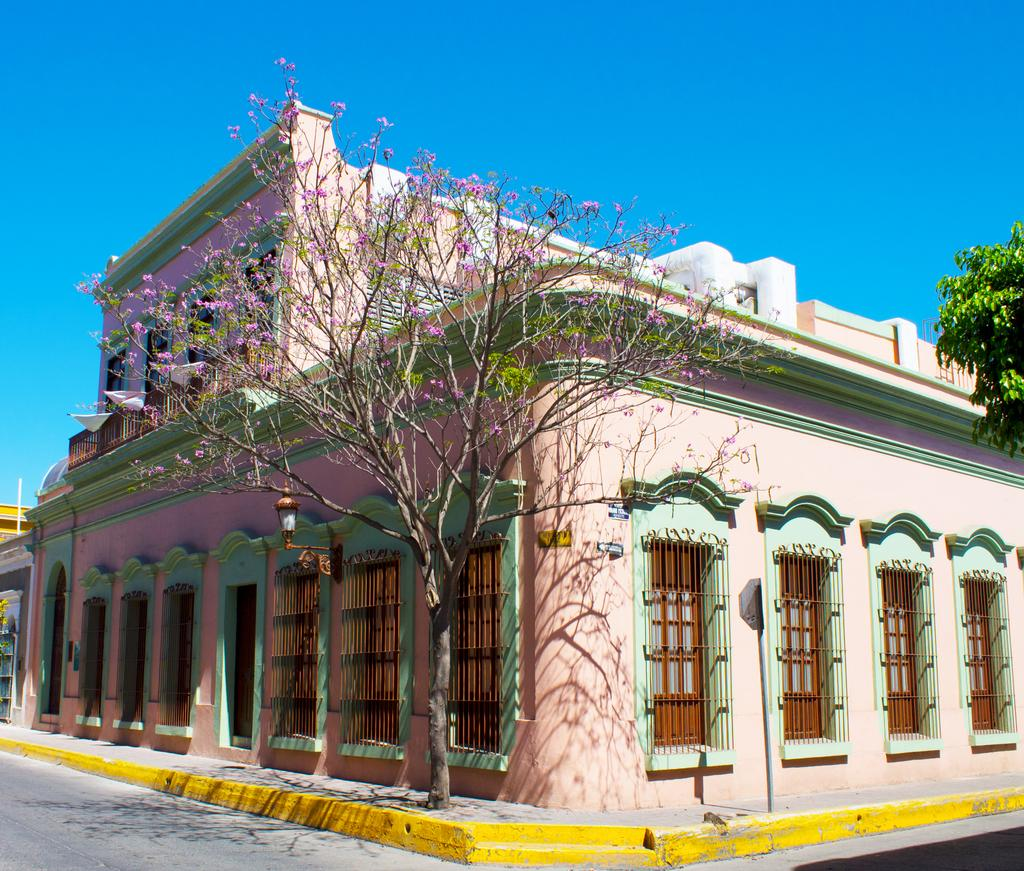What type of structures can be seen in the image? There are buildings in the image. What is located in front of the buildings? There are trees in front of the buildings. What object can be seen in the image that is typically used for displaying information or advertisements? There is a sign board in the image. What type of flora is present in the image? There are flowers in the image. What is the source of illumination in the image? There is a light in the image. How many rings are visible on the parent's finger in the image? There is no parent or rings present in the image. What type of bird can be seen interacting with the flowers in the image? There is no bird, such as a hen, present in the image. 